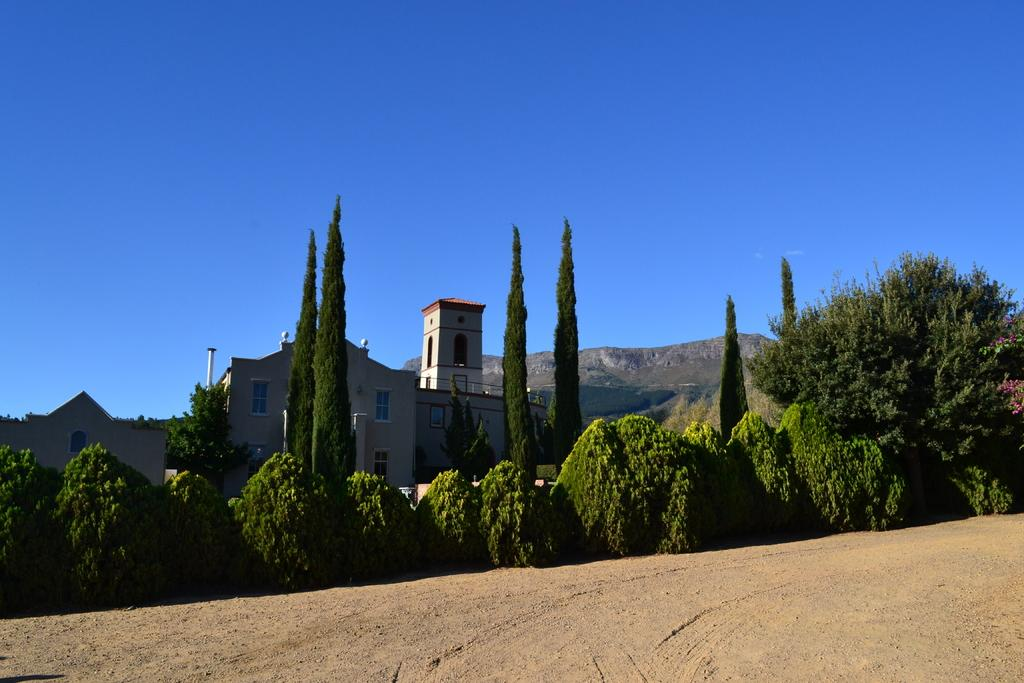What type of structures can be seen in the image? There are buildings in the image. What other natural elements are present in the image? There are trees in the image. What can be seen in the distance in the image? There are mountains in the background of the image. What type of toy can be seen in the image? There is no toy present in the image. How does the cough affect the buildings in the image? There is no cough present in the image, and therefore it cannot affect the buildings. 